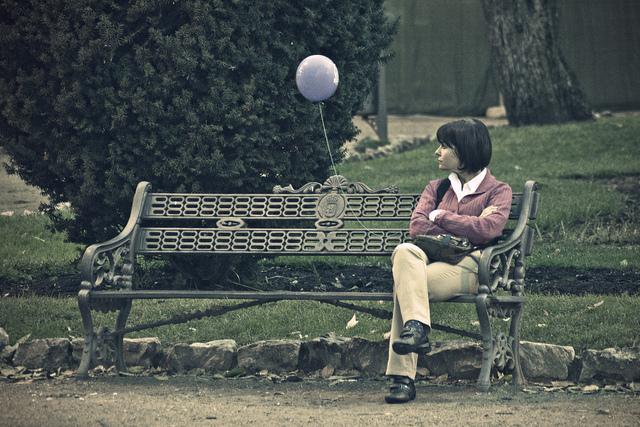How many people are sitting on the bench?
Give a very brief answer. 1. Where is the man seated?
Short answer required. Bench. What is floating the photo?
Be succinct. Balloon. 